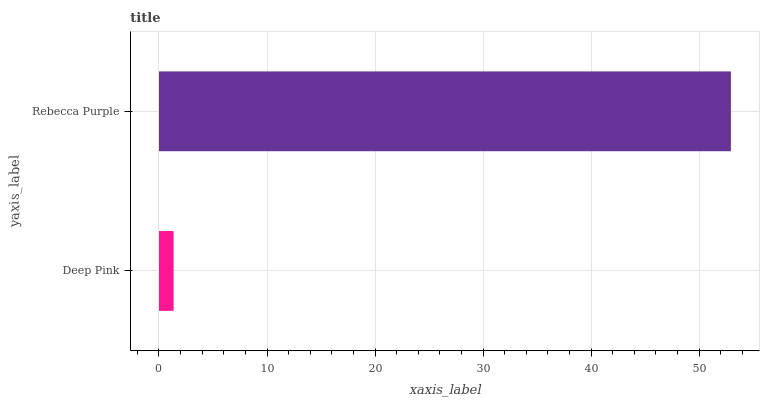Is Deep Pink the minimum?
Answer yes or no. Yes. Is Rebecca Purple the maximum?
Answer yes or no. Yes. Is Rebecca Purple the minimum?
Answer yes or no. No. Is Rebecca Purple greater than Deep Pink?
Answer yes or no. Yes. Is Deep Pink less than Rebecca Purple?
Answer yes or no. Yes. Is Deep Pink greater than Rebecca Purple?
Answer yes or no. No. Is Rebecca Purple less than Deep Pink?
Answer yes or no. No. Is Rebecca Purple the high median?
Answer yes or no. Yes. Is Deep Pink the low median?
Answer yes or no. Yes. Is Deep Pink the high median?
Answer yes or no. No. Is Rebecca Purple the low median?
Answer yes or no. No. 